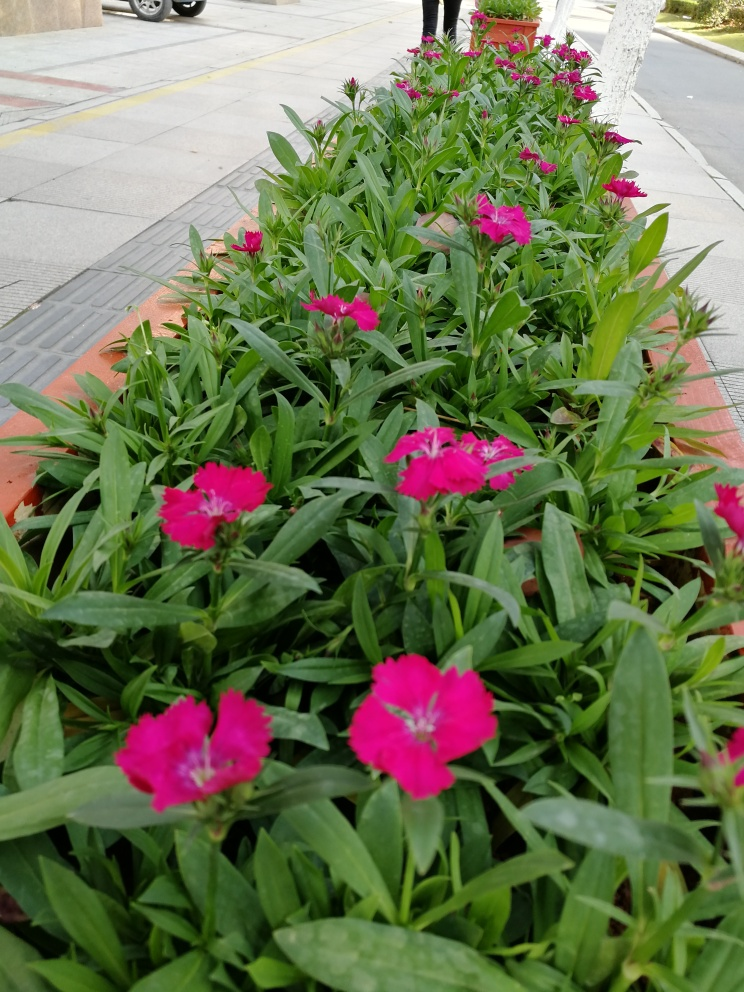What time of year is it likely to be, judging by the flowers in the image? Based on the healthy bloom of the flowers and the full, green leaves, it is likely to be late spring or summer. This is typically the peak blooming season for many flowering plants, including the type shown in the image. Could these flowers attract any specific type of wildlife? Yes, brightly colored flowers like these are often attractive to pollinators such as bees and butterflies. Their vivid colors and accessible nectar are designed by nature to draw in these creatures, which in turn helps the plants with pollination. 